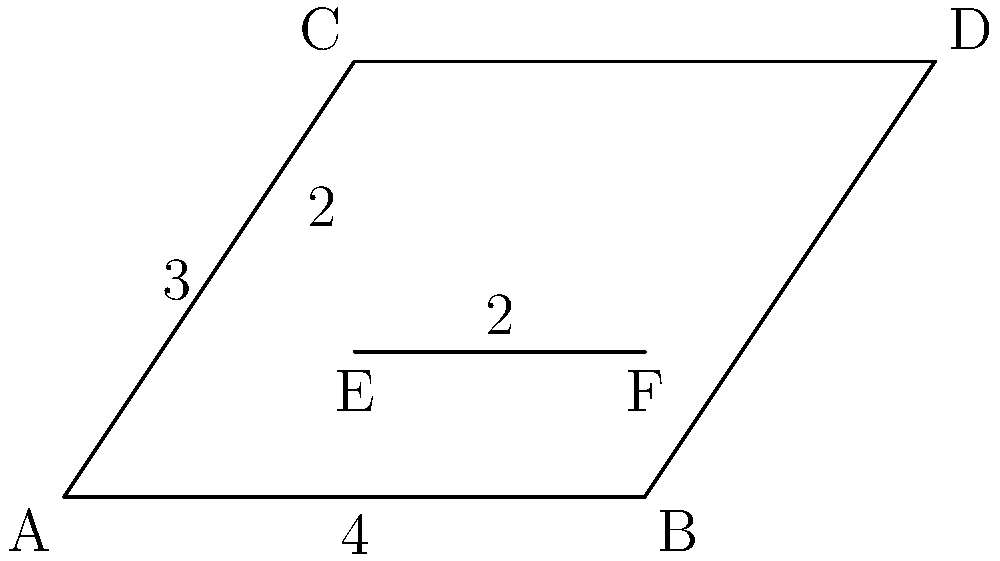A new basketball team is designing their logo. The logo is based on a trapezoid ABCD, with a line segment EF dividing it into two parts. If AE = 1, EB = 3, and EF is parallel to AB, what is the length of CD? Let's approach this step-by-step:

1) First, we need to recognize that triangles AEC and BFD are similar due to the parallel lines AB and EF.

2) We know that AE:EB = 1:3. This ratio will be maintained throughout the trapezoid due to the similarity of triangles.

3) Let's denote the length of CD as x. We can set up a proportion:

   $\frac{AB}{EF} = \frac{AD}{EF}$

4) We know AB = 4 and EF = 2 (given in the diagram). Let's substitute these values:

   $\frac{4}{2} = \frac{x}{2}$

5) Simplify:
   
   $2 = \frac{x}{2}$

6) Multiply both sides by 2:

   $4 = x$

Therefore, the length of CD is 4.
Answer: 4 